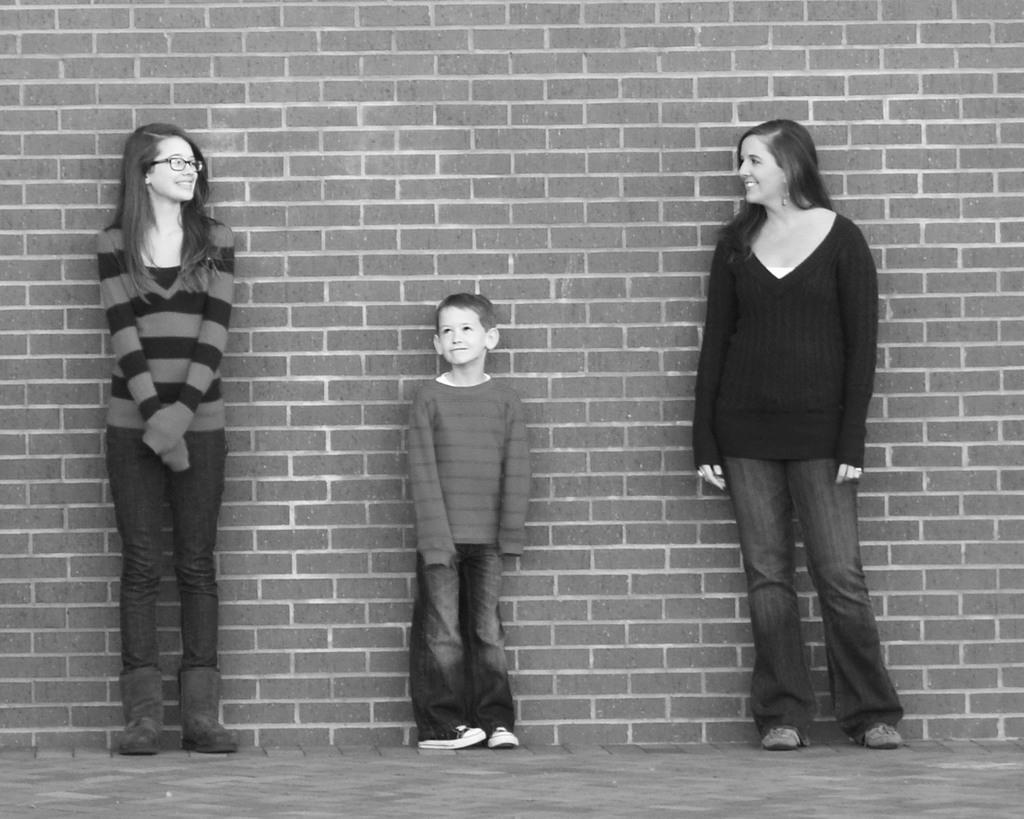How would you summarize this image in a sentence or two? This is a black and white pic. We can see a boy and two women are standing on the ground at the brick wall. 